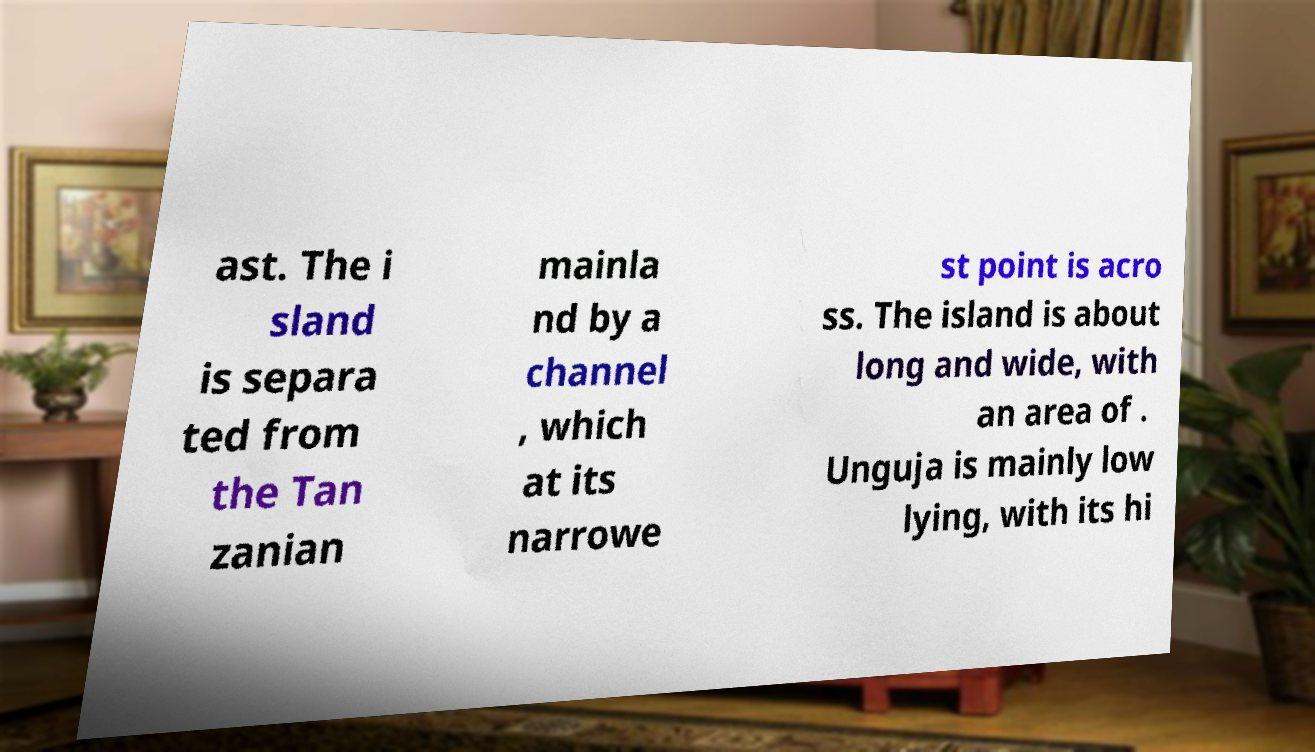What messages or text are displayed in this image? I need them in a readable, typed format. ast. The i sland is separa ted from the Tan zanian mainla nd by a channel , which at its narrowe st point is acro ss. The island is about long and wide, with an area of . Unguja is mainly low lying, with its hi 